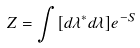<formula> <loc_0><loc_0><loc_500><loc_500>Z = \int [ d \lambda ^ { * } d \lambda ] e ^ { - S }</formula> 